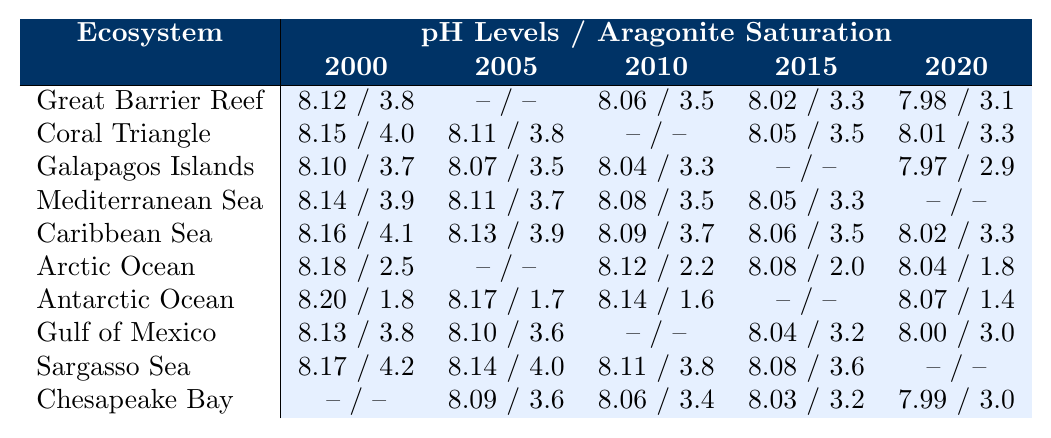What is the pH level of the Great Barrier Reef in 2020? The table shows the pH level for the Great Barrier Reef in 2020 as 7.98.
Answer: 7.98 What is the aragonite saturation for the Coral Triangle in 2005? According to the table, the aragonite saturation for the Coral Triangle in 2005 is 3.8.
Answer: 3.8 Which ecosystem has the lowest pH level recorded in the table? From the pH levels, the Arctic Ocean has the lowest value in 2020 at 8.04.
Answer: Arctic Ocean What is the aragonite saturation level increase from the Caribbean Sea in 2010 to 2020? The aragonite saturation for the Caribbean Sea in 2010 is 3.7 and in 2020 is 3.3. The difference is 3.7 - 3.3 = 0.4.
Answer: 0.4 What year shows the highest average pH level across all ecosystems in the table? To find the average for each year, we need to sum all available pH levels for each year. The average pH levels are calculated as follows: 
- 2000: (8.12 + 8.15 + 8.10 + 8.14 + 8.16 + 8.18 + 8.20 + 8.13 + 8.17 + 0) / 9 = 8.152 
- 2005: (0 + 8.11 + 8.07 + 8.11 + 8.13 + 0 + 8.17 + 8.10 + 8.14 + 8.09) / 9 = 8.095 
- 2010: (8.06 + 0 + 8.04 + 8.08 + 8.09 + 8.12 + 8.14 + 0 + 8.11 + 8.06) / 9 = 8.080 
- 2015: (8.02 + 8.05 + 0 + 8.05 + 8.06 + 8.08 + 0 + 8.04 + 8.08 + 8.03) / 9 = 8.048 
- 2020: (7.98 + 8.01 + 7.97 + 0 + 8.02 + 8.04 + 8.07 + 8.00 + 0 + 7.99) / 9 = 8.009 
The highest average is for 2000 at 8.152.
Answer: 2000 Is there any ecosystem that remains constant in pH levels over the recorded years? By examining the table, no ecosystem shows consistent pH levels across all years; fluctuations are present for every ecosystem.
Answer: No What is the trend of aragonite saturation in the Arctic Ocean from 2000 to 2020? The values for the Arctic Ocean over these years are: 2.5 (2000), -- (2005), 2.2 (2010), 2.0 (2015), 1.8 (2020). The trend is a decrease from 2.5 to 2.0 and further down to 1.8.
Answer: Decreasing Which year had the highest recorded aragonite saturation across all ecosystems? The table indicates the highest aragonite saturation in the year 2000 for the Caribbean Sea with a value of 4.1.
Answer: 2000 How does the pH level of the Sargasso Sea change from 2000 to 2015? The pH levels for the Sargasso Sea in those years are 8.17 (2000) and 8.08 (2015). The change indicates a decrease of 0.09.
Answer: Decrease of 0.09 What was the average aragonite saturation across all ecosystems in 2015? The aragonite saturation values for the year 2015 are (3.3 + 3.5 + 3.3 + 3.5 + 3.2 + 0 + 0 + 3.6 + 3.6 + 3.2) / 8 = 3.36, considering only the valid data points.
Answer: 3.36 